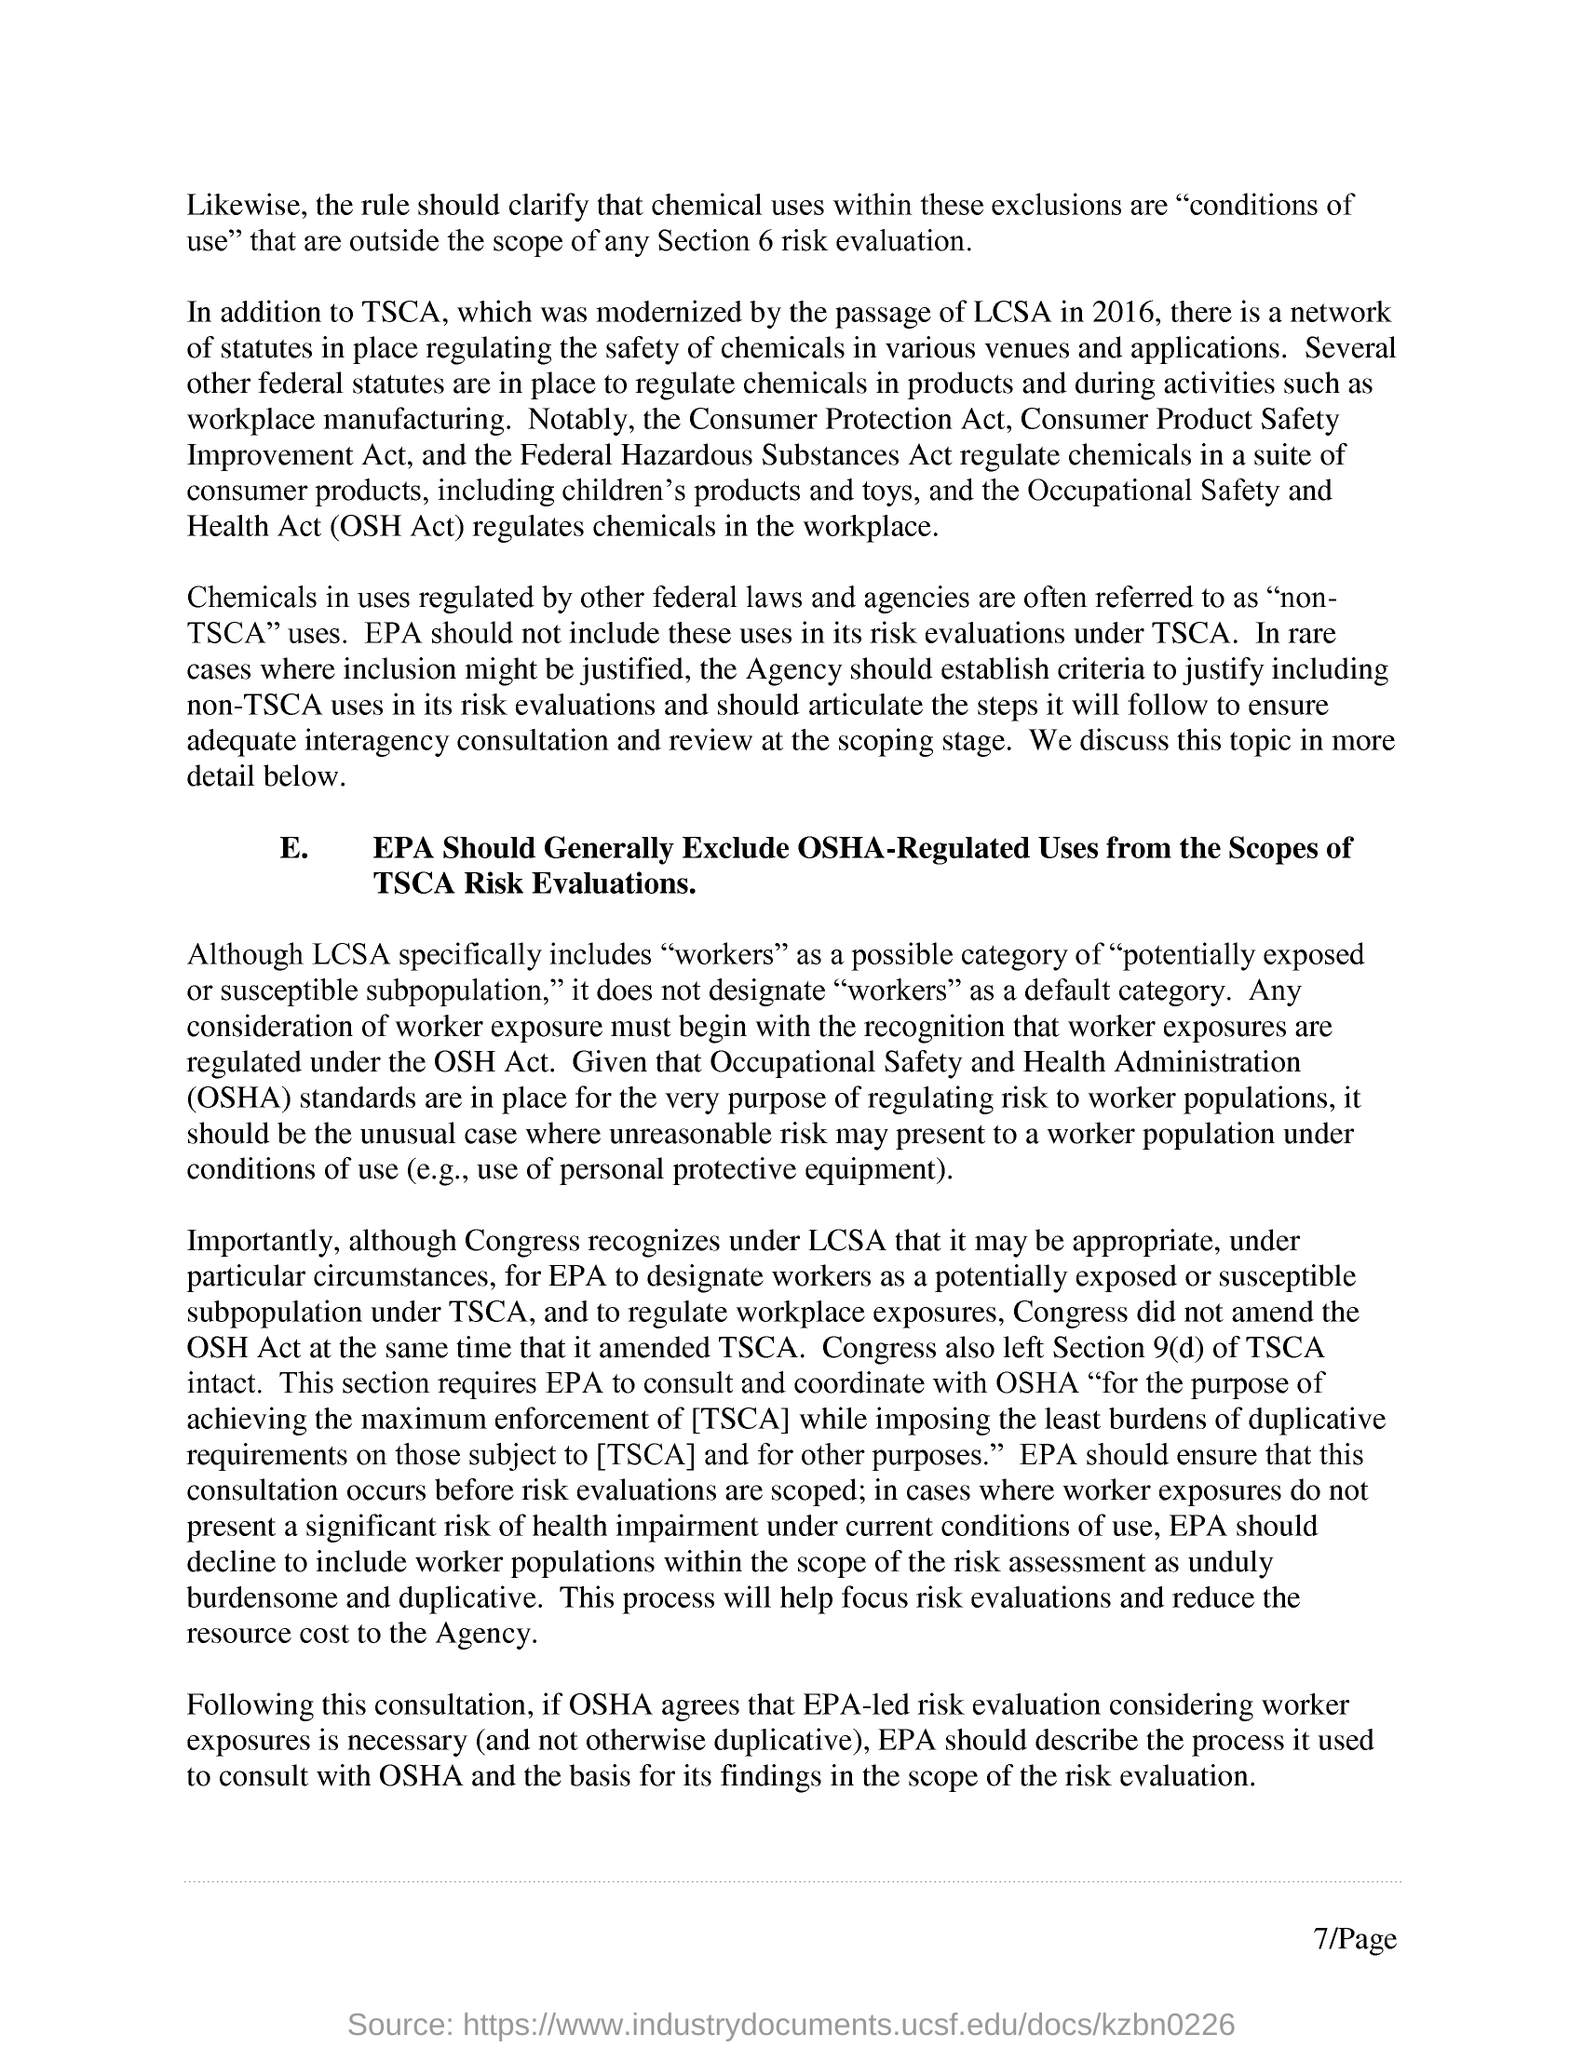What is the Page Number?
Offer a very short reply. 7. 